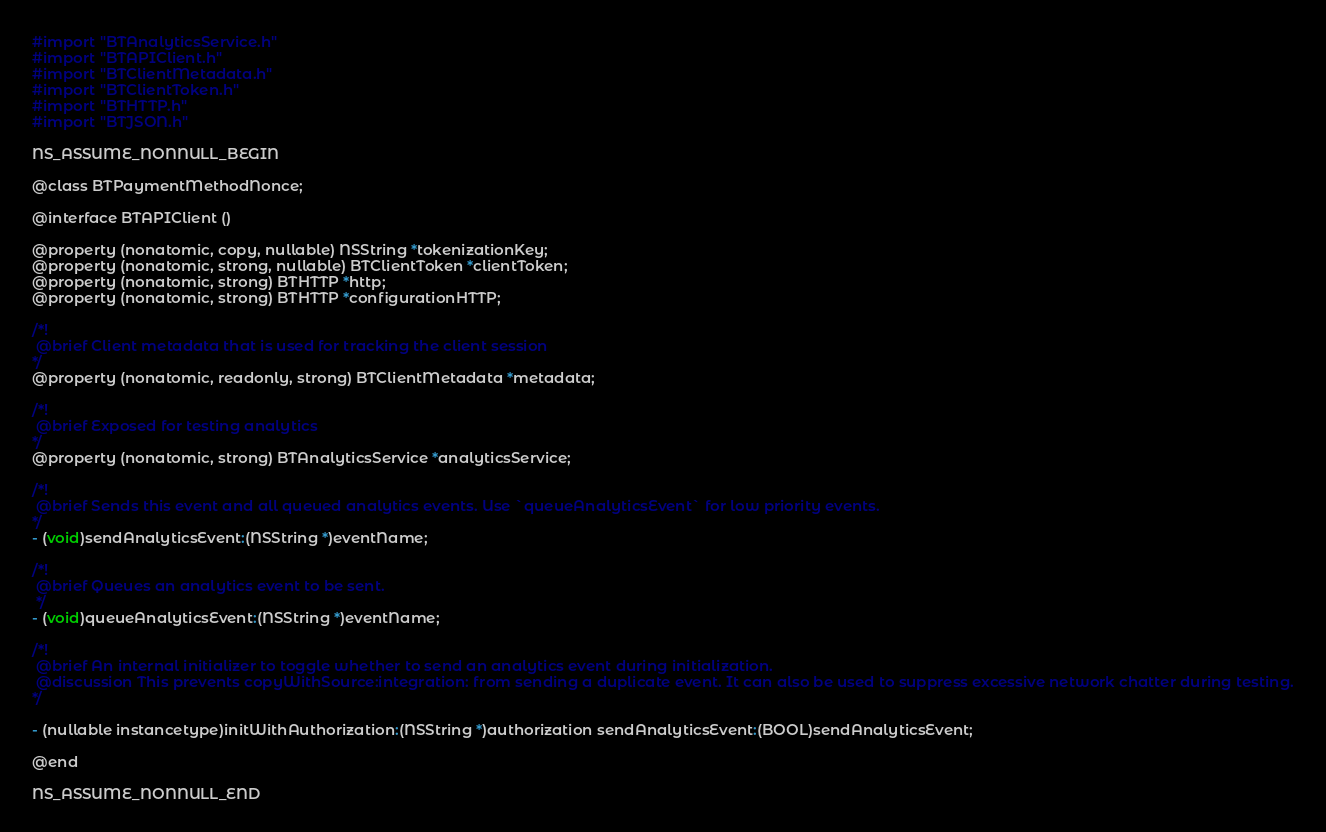<code> <loc_0><loc_0><loc_500><loc_500><_C_>#import "BTAnalyticsService.h"
#import "BTAPIClient.h"
#import "BTClientMetadata.h"
#import "BTClientToken.h"
#import "BTHTTP.h"
#import "BTJSON.h"

NS_ASSUME_NONNULL_BEGIN

@class BTPaymentMethodNonce;

@interface BTAPIClient ()

@property (nonatomic, copy, nullable) NSString *tokenizationKey;
@property (nonatomic, strong, nullable) BTClientToken *clientToken;
@property (nonatomic, strong) BTHTTP *http;
@property (nonatomic, strong) BTHTTP *configurationHTTP;

/*!
 @brief Client metadata that is used for tracking the client session
*/
@property (nonatomic, readonly, strong) BTClientMetadata *metadata;

/*!
 @brief Exposed for testing analytics
*/
@property (nonatomic, strong) BTAnalyticsService *analyticsService;

/*!
 @brief Sends this event and all queued analytics events. Use `queueAnalyticsEvent` for low priority events.
*/
- (void)sendAnalyticsEvent:(NSString *)eventName;

/*!
 @brief Queues an analytics event to be sent.
 */
- (void)queueAnalyticsEvent:(NSString *)eventName;

/*!
 @brief An internal initializer to toggle whether to send an analytics event during initialization.
 @discussion This prevents copyWithSource:integration: from sending a duplicate event. It can also be used to suppress excessive network chatter during testing.
*/

- (nullable instancetype)initWithAuthorization:(NSString *)authorization sendAnalyticsEvent:(BOOL)sendAnalyticsEvent;

@end

NS_ASSUME_NONNULL_END
</code> 